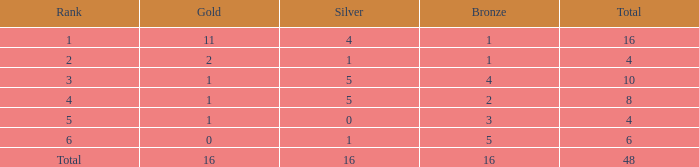What quantity of gold is less than 4 in total? 0.0. 